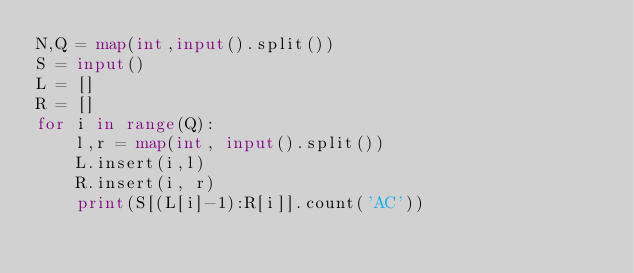<code> <loc_0><loc_0><loc_500><loc_500><_Python_>N,Q = map(int,input().split())
S = input()
L = []
R = []
for i in range(Q):
    l,r = map(int, input().split())
    L.insert(i,l)
    R.insert(i, r)
    print(S[(L[i]-1):R[i]].count('AC'))</code> 